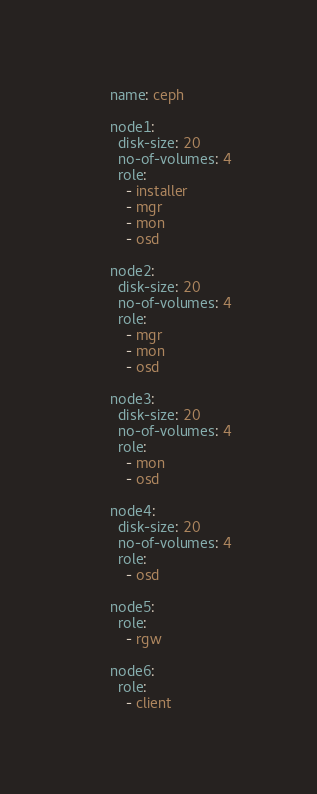Convert code to text. <code><loc_0><loc_0><loc_500><loc_500><_YAML_>      name: ceph

      node1:
        disk-size: 20
        no-of-volumes: 4
        role:
          - installer
          - mgr
          - mon
          - osd

      node2:
        disk-size: 20
        no-of-volumes: 4
        role:
          - mgr
          - mon
          - osd

      node3:
        disk-size: 20
        no-of-volumes: 4
        role:
          - mon
          - osd

      node4:
        disk-size: 20
        no-of-volumes: 4
        role:
          - osd

      node5:
        role:
          - rgw

      node6:
        role:
          - client
</code> 